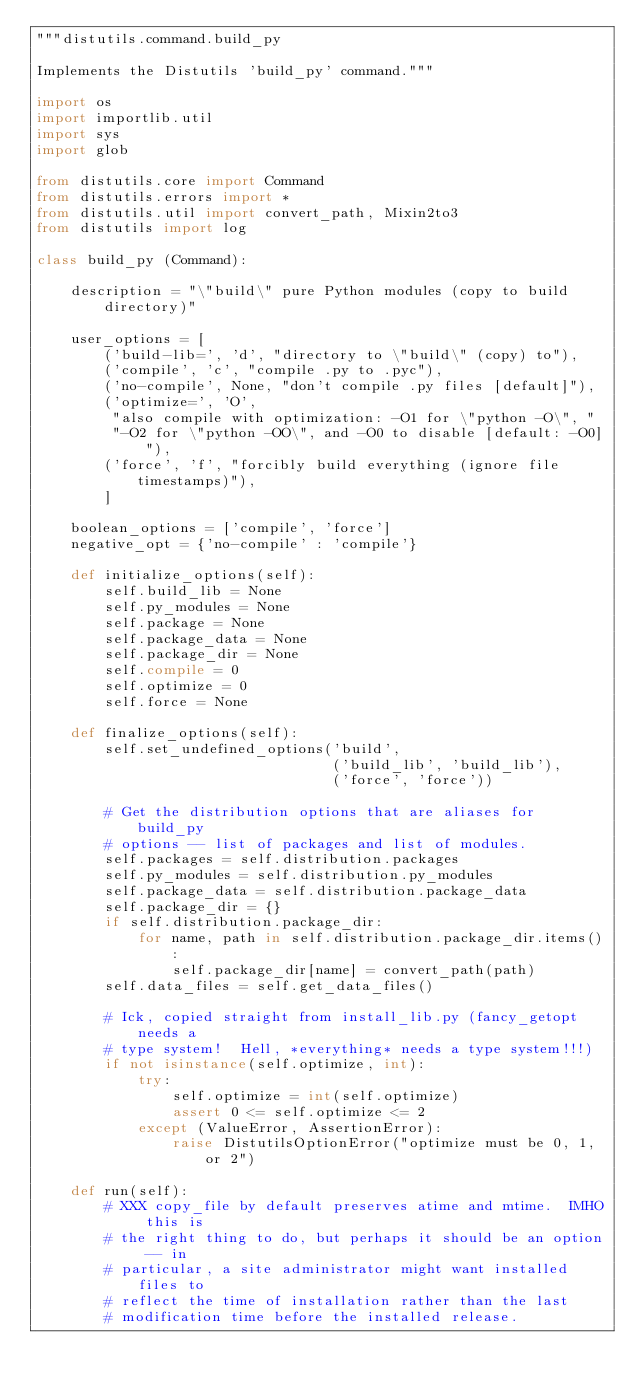Convert code to text. <code><loc_0><loc_0><loc_500><loc_500><_Python_>"""distutils.command.build_py

Implements the Distutils 'build_py' command."""

import os
import importlib.util
import sys
import glob

from distutils.core import Command
from distutils.errors import *
from distutils.util import convert_path, Mixin2to3
from distutils import log

class build_py (Command):

    description = "\"build\" pure Python modules (copy to build directory)"

    user_options = [
        ('build-lib=', 'd', "directory to \"build\" (copy) to"),
        ('compile', 'c', "compile .py to .pyc"),
        ('no-compile', None, "don't compile .py files [default]"),
        ('optimize=', 'O',
         "also compile with optimization: -O1 for \"python -O\", "
         "-O2 for \"python -OO\", and -O0 to disable [default: -O0]"),
        ('force', 'f', "forcibly build everything (ignore file timestamps)"),
        ]

    boolean_options = ['compile', 'force']
    negative_opt = {'no-compile' : 'compile'}

    def initialize_options(self):
        self.build_lib = None
        self.py_modules = None
        self.package = None
        self.package_data = None
        self.package_dir = None
        self.compile = 0
        self.optimize = 0
        self.force = None

    def finalize_options(self):
        self.set_undefined_options('build',
                                   ('build_lib', 'build_lib'),
                                   ('force', 'force'))

        # Get the distribution options that are aliases for build_py
        # options -- list of packages and list of modules.
        self.packages = self.distribution.packages
        self.py_modules = self.distribution.py_modules
        self.package_data = self.distribution.package_data
        self.package_dir = {}
        if self.distribution.package_dir:
            for name, path in self.distribution.package_dir.items():
                self.package_dir[name] = convert_path(path)
        self.data_files = self.get_data_files()

        # Ick, copied straight from install_lib.py (fancy_getopt needs a
        # type system!  Hell, *everything* needs a type system!!!)
        if not isinstance(self.optimize, int):
            try:
                self.optimize = int(self.optimize)
                assert 0 <= self.optimize <= 2
            except (ValueError, AssertionError):
                raise DistutilsOptionError("optimize must be 0, 1, or 2")

    def run(self):
        # XXX copy_file by default preserves atime and mtime.  IMHO this is
        # the right thing to do, but perhaps it should be an option -- in
        # particular, a site administrator might want installed files to
        # reflect the time of installation rather than the last
        # modification time before the installed release.
</code> 